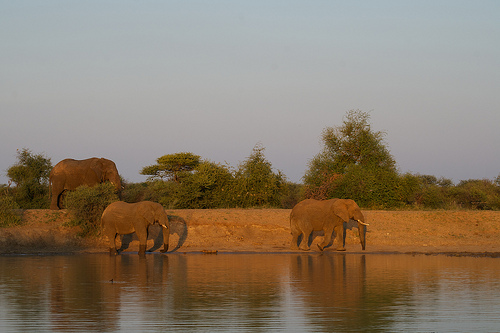How many elephants are shown? 3 